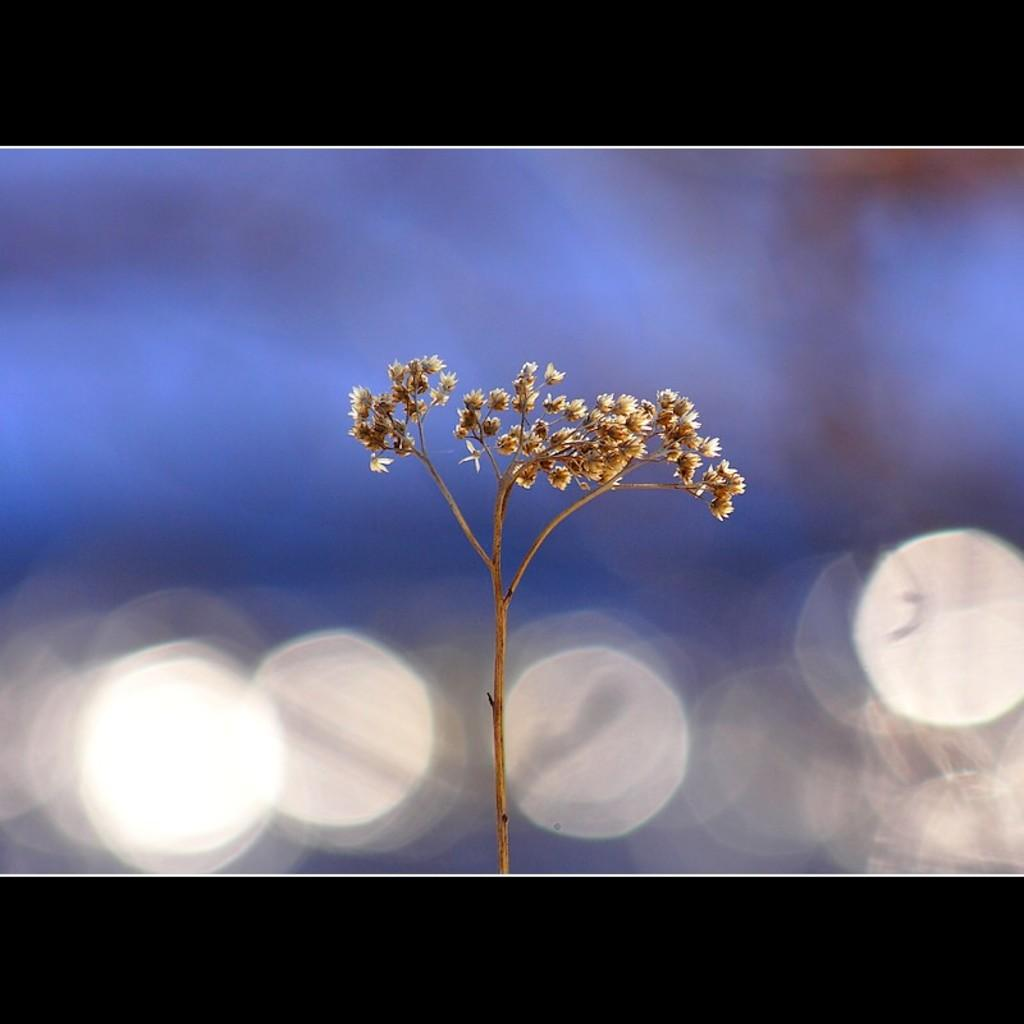What type of plant is visible in the image? There is a plant in the image. What additional features can be seen on the plant? There are flowers in the image. Can you describe the background of the image? The background of the image is blurry. What type of sign can be seen in the image? There is no sign present in the image. How does the aftermath of the event affect the plant in the image? There is no event mentioned in the image, so it is not possible to discuss its aftermath. 